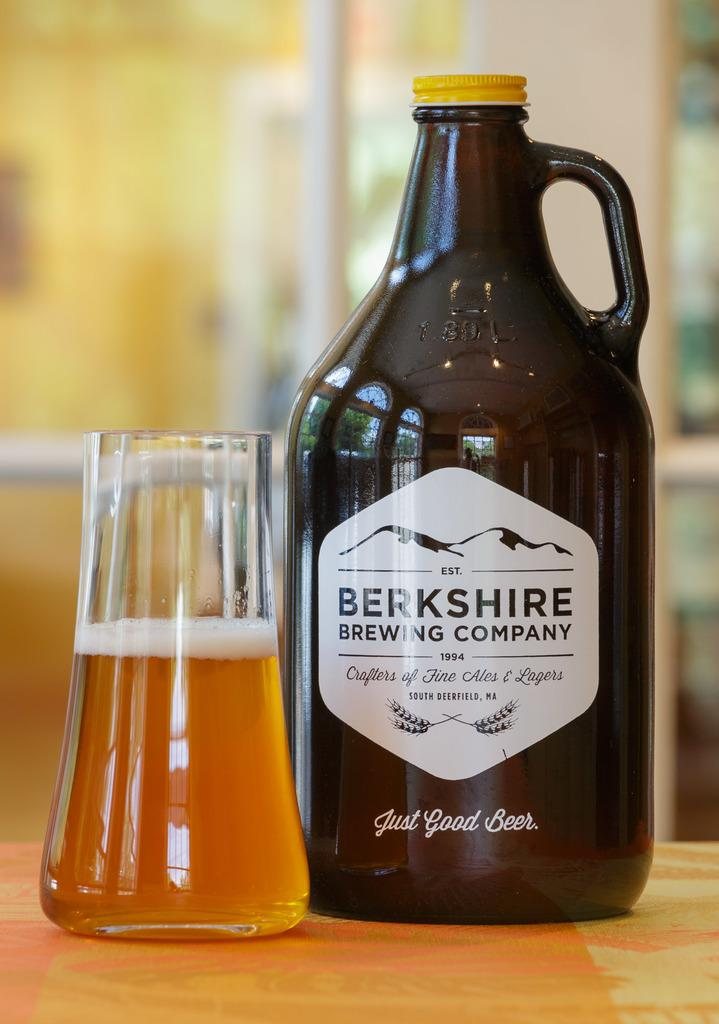<image>
Render a clear and concise summary of the photo. a jug and glass of Berkshire Brewing Company beer 